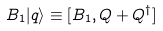<formula> <loc_0><loc_0><loc_500><loc_500>B _ { 1 } | q \rangle \equiv [ B _ { 1 } , Q + Q ^ { \dag } ]</formula> 